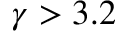<formula> <loc_0><loc_0><loc_500><loc_500>\gamma > 3 . 2</formula> 